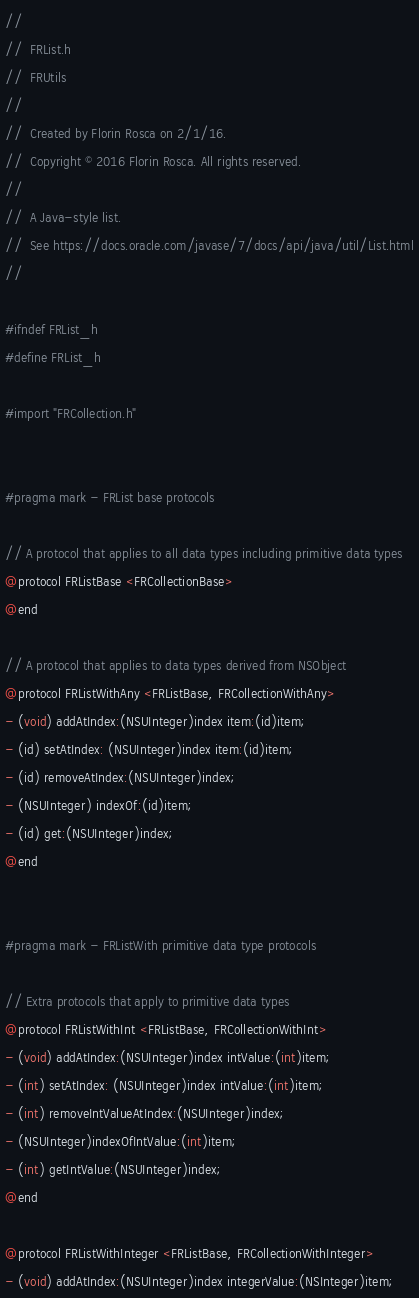<code> <loc_0><loc_0><loc_500><loc_500><_C_>//
//  FRList.h
//  FRUtils
//
//  Created by Florin Rosca on 2/1/16.
//  Copyright © 2016 Florin Rosca. All rights reserved.
//
//  A Java-style list.
//  See https://docs.oracle.com/javase/7/docs/api/java/util/List.html
//

#ifndef FRList_h
#define FRList_h

#import "FRCollection.h"


#pragma mark - FRList base protocols

// A protocol that applies to all data types including primitive data types
@protocol FRListBase <FRCollectionBase>
@end

// A protocol that applies to data types derived from NSObject
@protocol FRListWithAny <FRListBase, FRCollectionWithAny>
- (void) addAtIndex:(NSUInteger)index item:(id)item;
- (id) setAtIndex: (NSUInteger)index item:(id)item;
- (id) removeAtIndex:(NSUInteger)index;
- (NSUInteger) indexOf:(id)item;
- (id) get:(NSUInteger)index;
@end


#pragma mark - FRListWith primitive data type protocols

// Extra protocols that apply to primitive data types
@protocol FRListWithInt <FRListBase, FRCollectionWithInt>
- (void) addAtIndex:(NSUInteger)index intValue:(int)item;
- (int) setAtIndex: (NSUInteger)index intValue:(int)item;
- (int) removeIntValueAtIndex:(NSUInteger)index;
- (NSUInteger)indexOfIntValue:(int)item;
- (int) getIntValue:(NSUInteger)index;
@end

@protocol FRListWithInteger <FRListBase, FRCollectionWithInteger>
- (void) addAtIndex:(NSUInteger)index integerValue:(NSInteger)item;</code> 